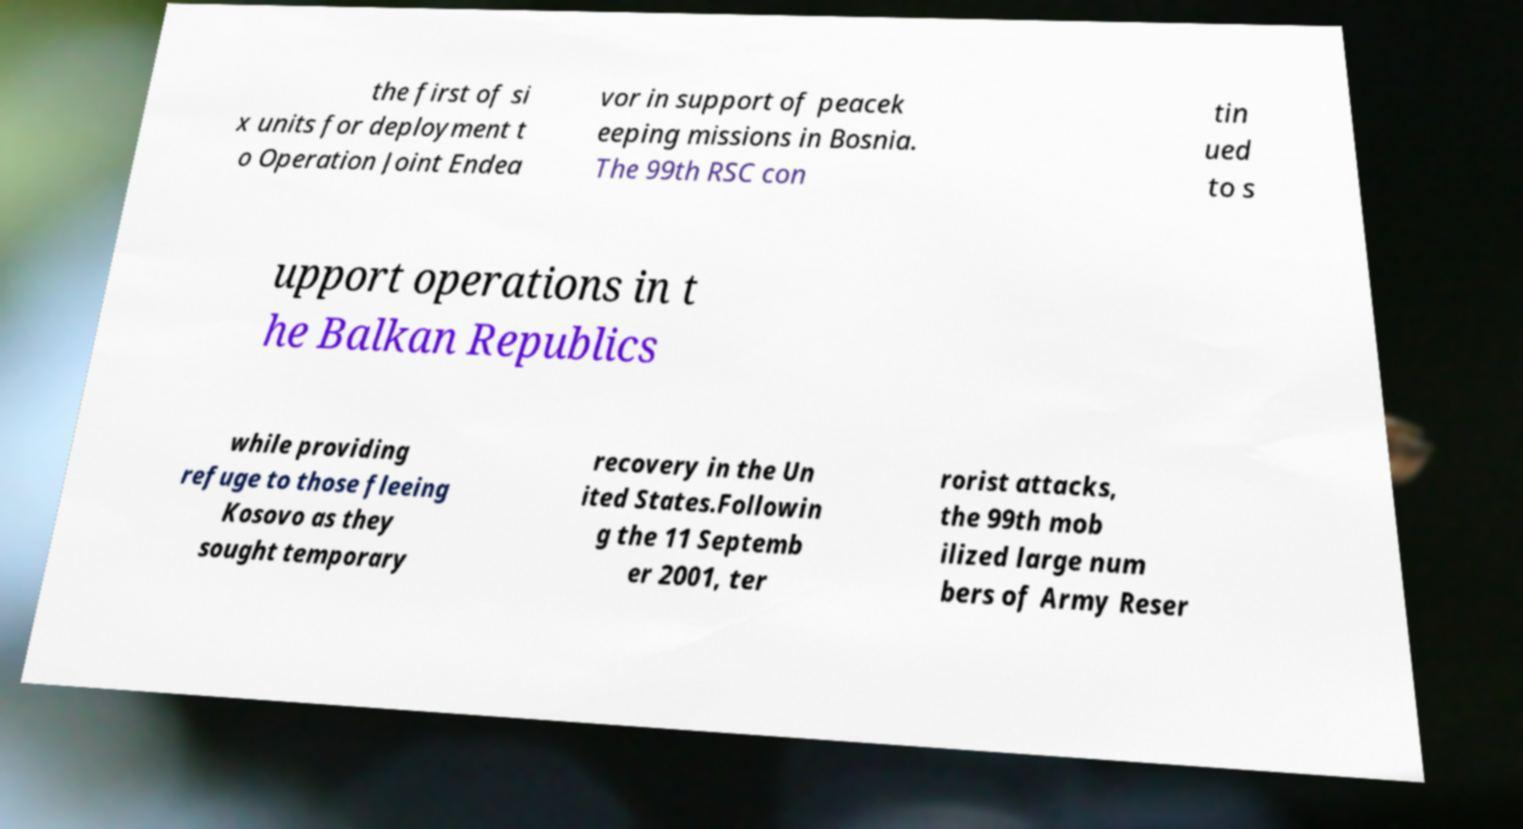Could you extract and type out the text from this image? the first of si x units for deployment t o Operation Joint Endea vor in support of peacek eeping missions in Bosnia. The 99th RSC con tin ued to s upport operations in t he Balkan Republics while providing refuge to those fleeing Kosovo as they sought temporary recovery in the Un ited States.Followin g the 11 Septemb er 2001, ter rorist attacks, the 99th mob ilized large num bers of Army Reser 